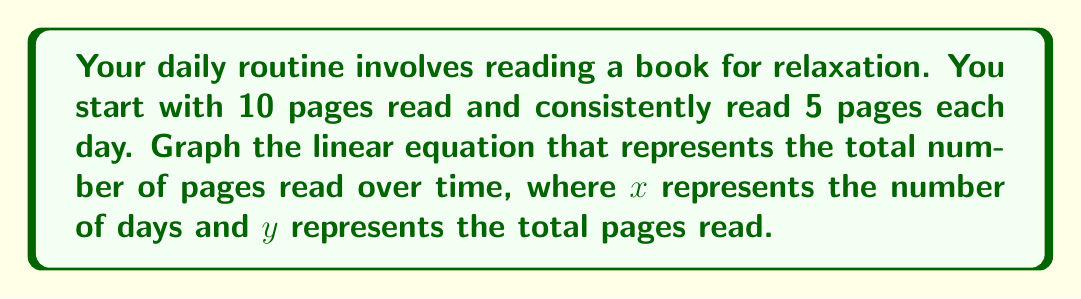Could you help me with this problem? Let's approach this step-by-step:

1) First, we need to identify the components of our linear equation:
   - Initial value (y-intercept): 10 pages
   - Rate of change (slope): 5 pages per day

2) The general form of a linear equation is $y = mx + b$, where:
   $m$ = slope
   $b$ = y-intercept

3) Plugging in our values:
   $y = 5x + 10$

4) To graph this equation, we'll plot points and connect them:
   - When $x = 0$, $y = 5(0) + 10 = 10$
   - When $x = 1$, $y = 5(1) + 10 = 15$
   - When $x = 2$, $y = 5(2) + 10 = 20$
   - When $x = 3$, $y = 5(3) + 10 = 25$

5) Now, let's plot these points and connect them:

[asy]
import graph;
size(200);
real f(real x) {return 5x + 10;}
xaxis("Days",Ticks);
yaxis("Pages Read",Ticks);
draw(graph(f,0,4),blue);
dot((0,10));
dot((1,15));
dot((2,20));
dot((3,25));
label("(0,10)",(0,10),SW);
label("(1,15)",(1,15),SE);
label("(2,20)",(2,20),SE);
label("(3,25)",(3,25),SE);
[/asy]

This graph represents a steady, predictable increase in the number of pages read over time, which aligns with a comfortable, consistent daily routine.
Answer: $y = 5x + 10$ 